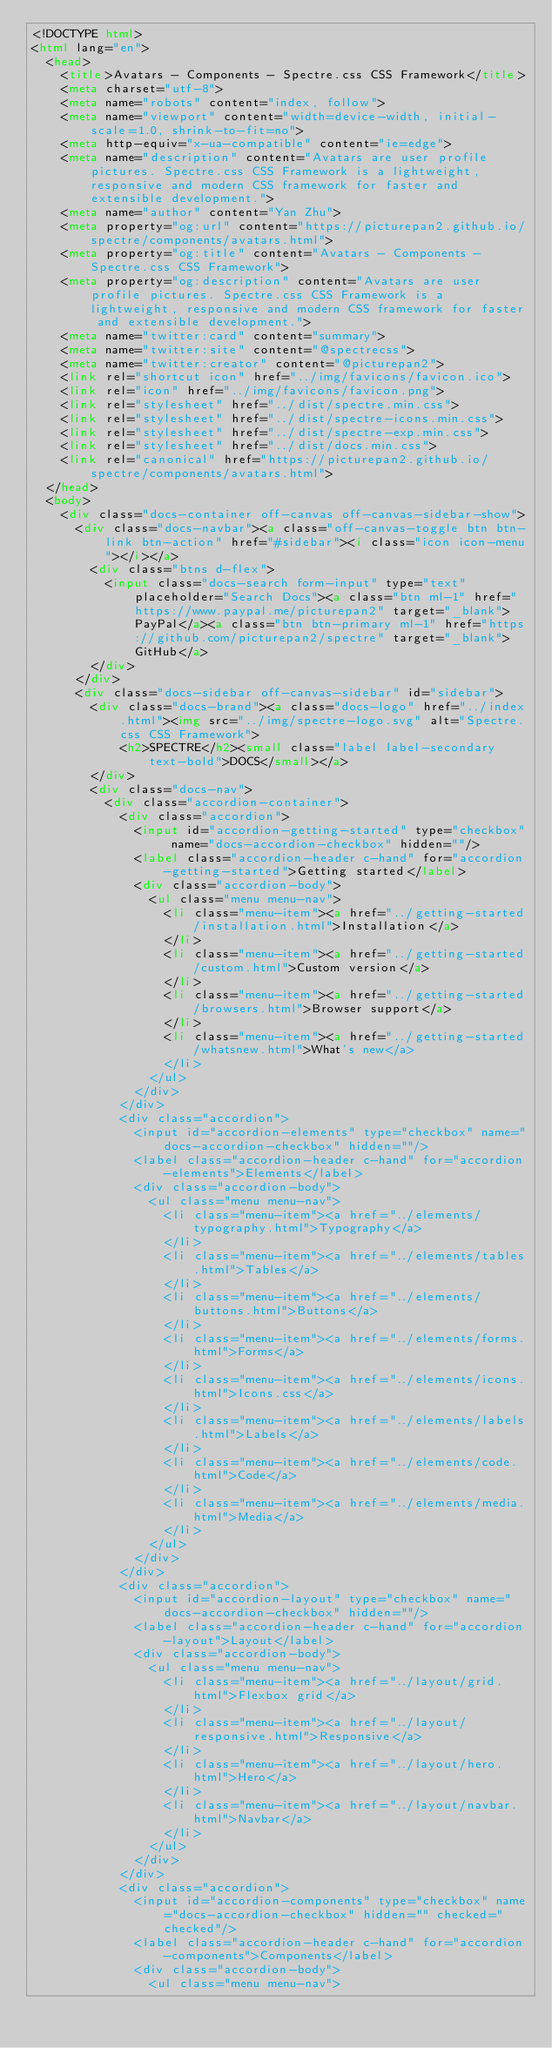Convert code to text. <code><loc_0><loc_0><loc_500><loc_500><_HTML_><!DOCTYPE html>
<html lang="en">
  <head>
    <title>Avatars - Components - Spectre.css CSS Framework</title>
    <meta charset="utf-8">
    <meta name="robots" content="index, follow">
    <meta name="viewport" content="width=device-width, initial-scale=1.0, shrink-to-fit=no">
    <meta http-equiv="x-ua-compatible" content="ie=edge">
    <meta name="description" content="Avatars are user profile pictures. Spectre.css CSS Framework is a lightweight, responsive and modern CSS framework for faster and extensible development.">
    <meta name="author" content="Yan Zhu">
    <meta property="og:url" content="https://picturepan2.github.io/spectre/components/avatars.html">
    <meta property="og:title" content="Avatars - Components - Spectre.css CSS Framework">
    <meta property="og:description" content="Avatars are user profile pictures. Spectre.css CSS Framework is a lightweight, responsive and modern CSS framework for faster and extensible development.">
    <meta name="twitter:card" content="summary">
    <meta name="twitter:site" content="@spectrecss">
    <meta name="twitter:creator" content="@picturepan2">
    <link rel="shortcut icon" href="../img/favicons/favicon.ico">
    <link rel="icon" href="../img/favicons/favicon.png">
    <link rel="stylesheet" href="../dist/spectre.min.css">
    <link rel="stylesheet" href="../dist/spectre-icons.min.css">
    <link rel="stylesheet" href="../dist/spectre-exp.min.css">
    <link rel="stylesheet" href="../dist/docs.min.css">
    <link rel="canonical" href="https://picturepan2.github.io/spectre/components/avatars.html">
  </head>
  <body>
    <div class="docs-container off-canvas off-canvas-sidebar-show">
      <div class="docs-navbar"><a class="off-canvas-toggle btn btn-link btn-action" href="#sidebar"><i class="icon icon-menu"></i></a>
        <div class="btns d-flex">
          <input class="docs-search form-input" type="text" placeholder="Search Docs"><a class="btn ml-1" href="https://www.paypal.me/picturepan2" target="_blank">PayPal</a><a class="btn btn-primary ml-1" href="https://github.com/picturepan2/spectre" target="_blank">GitHub</a>
        </div>
      </div>
      <div class="docs-sidebar off-canvas-sidebar" id="sidebar">
        <div class="docs-brand"><a class="docs-logo" href="../index.html"><img src="../img/spectre-logo.svg" alt="Spectre.css CSS Framework">
            <h2>SPECTRE</h2><small class="label label-secondary text-bold">DOCS</small></a>
        </div>
        <div class="docs-nav">
          <div class="accordion-container">
            <div class="accordion">
              <input id="accordion-getting-started" type="checkbox" name="docs-accordion-checkbox" hidden=""/>
              <label class="accordion-header c-hand" for="accordion-getting-started">Getting started</label>
              <div class="accordion-body">
                <ul class="menu menu-nav">
                  <li class="menu-item"><a href="../getting-started/installation.html">Installation</a>
                  </li>
                  <li class="menu-item"><a href="../getting-started/custom.html">Custom version</a>
                  </li>
                  <li class="menu-item"><a href="../getting-started/browsers.html">Browser support</a>
                  </li>
                  <li class="menu-item"><a href="../getting-started/whatsnew.html">What's new</a>
                  </li>
                </ul>
              </div>
            </div>
            <div class="accordion">
              <input id="accordion-elements" type="checkbox" name="docs-accordion-checkbox" hidden=""/>
              <label class="accordion-header c-hand" for="accordion-elements">Elements</label>
              <div class="accordion-body">
                <ul class="menu menu-nav">
                  <li class="menu-item"><a href="../elements/typography.html">Typography</a>
                  </li>
                  <li class="menu-item"><a href="../elements/tables.html">Tables</a>
                  </li>
                  <li class="menu-item"><a href="../elements/buttons.html">Buttons</a>
                  </li>
                  <li class="menu-item"><a href="../elements/forms.html">Forms</a>
                  </li>
                  <li class="menu-item"><a href="../elements/icons.html">Icons.css</a>
                  </li>
                  <li class="menu-item"><a href="../elements/labels.html">Labels</a>
                  </li>
                  <li class="menu-item"><a href="../elements/code.html">Code</a>
                  </li>
                  <li class="menu-item"><a href="../elements/media.html">Media</a>
                  </li>
                </ul>
              </div>
            </div>
            <div class="accordion">
              <input id="accordion-layout" type="checkbox" name="docs-accordion-checkbox" hidden=""/>
              <label class="accordion-header c-hand" for="accordion-layout">Layout</label>
              <div class="accordion-body">
                <ul class="menu menu-nav">
                  <li class="menu-item"><a href="../layout/grid.html">Flexbox grid</a>
                  </li>
                  <li class="menu-item"><a href="../layout/responsive.html">Responsive</a>
                  </li>
                  <li class="menu-item"><a href="../layout/hero.html">Hero</a>
                  </li>
                  <li class="menu-item"><a href="../layout/navbar.html">Navbar</a>
                  </li>
                </ul>
              </div>
            </div>
            <div class="accordion">
              <input id="accordion-components" type="checkbox" name="docs-accordion-checkbox" hidden="" checked="checked"/>
              <label class="accordion-header c-hand" for="accordion-components">Components</label>
              <div class="accordion-body">
                <ul class="menu menu-nav"></code> 